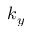<formula> <loc_0><loc_0><loc_500><loc_500>k _ { y }</formula> 